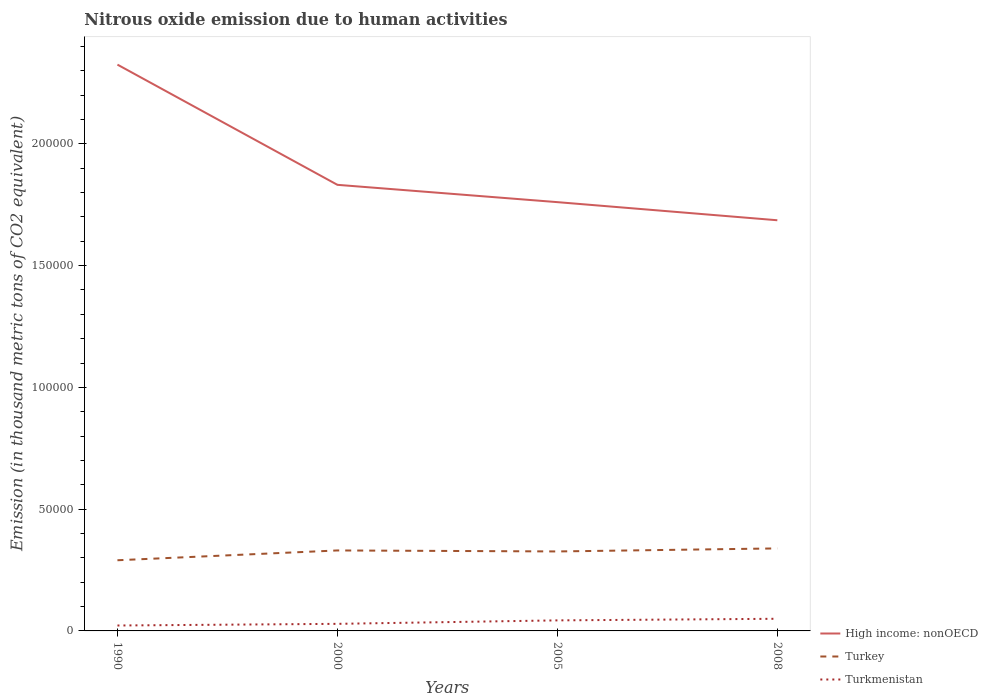Does the line corresponding to Turkey intersect with the line corresponding to Turkmenistan?
Your answer should be very brief. No. Across all years, what is the maximum amount of nitrous oxide emitted in High income: nonOECD?
Your answer should be compact. 1.69e+05. What is the total amount of nitrous oxide emitted in Turkey in the graph?
Keep it short and to the point. -1246.8. What is the difference between the highest and the second highest amount of nitrous oxide emitted in Turkey?
Your response must be concise. 4864.2. How many lines are there?
Your answer should be very brief. 3. How many years are there in the graph?
Make the answer very short. 4. What is the difference between two consecutive major ticks on the Y-axis?
Ensure brevity in your answer.  5.00e+04. Are the values on the major ticks of Y-axis written in scientific E-notation?
Your answer should be compact. No. How are the legend labels stacked?
Make the answer very short. Vertical. What is the title of the graph?
Offer a terse response. Nitrous oxide emission due to human activities. Does "French Polynesia" appear as one of the legend labels in the graph?
Provide a succinct answer. No. What is the label or title of the Y-axis?
Provide a short and direct response. Emission (in thousand metric tons of CO2 equivalent). What is the Emission (in thousand metric tons of CO2 equivalent) in High income: nonOECD in 1990?
Your answer should be compact. 2.33e+05. What is the Emission (in thousand metric tons of CO2 equivalent) in Turkey in 1990?
Provide a short and direct response. 2.90e+04. What is the Emission (in thousand metric tons of CO2 equivalent) of Turkmenistan in 1990?
Offer a very short reply. 2225.1. What is the Emission (in thousand metric tons of CO2 equivalent) of High income: nonOECD in 2000?
Give a very brief answer. 1.83e+05. What is the Emission (in thousand metric tons of CO2 equivalent) of Turkey in 2000?
Provide a succinct answer. 3.30e+04. What is the Emission (in thousand metric tons of CO2 equivalent) of Turkmenistan in 2000?
Provide a short and direct response. 2907.9. What is the Emission (in thousand metric tons of CO2 equivalent) of High income: nonOECD in 2005?
Give a very brief answer. 1.76e+05. What is the Emission (in thousand metric tons of CO2 equivalent) in Turkey in 2005?
Offer a terse response. 3.26e+04. What is the Emission (in thousand metric tons of CO2 equivalent) of Turkmenistan in 2005?
Provide a short and direct response. 4330.6. What is the Emission (in thousand metric tons of CO2 equivalent) in High income: nonOECD in 2008?
Keep it short and to the point. 1.69e+05. What is the Emission (in thousand metric tons of CO2 equivalent) of Turkey in 2008?
Your response must be concise. 3.39e+04. What is the Emission (in thousand metric tons of CO2 equivalent) of Turkmenistan in 2008?
Keep it short and to the point. 4987.1. Across all years, what is the maximum Emission (in thousand metric tons of CO2 equivalent) in High income: nonOECD?
Offer a terse response. 2.33e+05. Across all years, what is the maximum Emission (in thousand metric tons of CO2 equivalent) of Turkey?
Your response must be concise. 3.39e+04. Across all years, what is the maximum Emission (in thousand metric tons of CO2 equivalent) in Turkmenistan?
Make the answer very short. 4987.1. Across all years, what is the minimum Emission (in thousand metric tons of CO2 equivalent) of High income: nonOECD?
Offer a very short reply. 1.69e+05. Across all years, what is the minimum Emission (in thousand metric tons of CO2 equivalent) of Turkey?
Your answer should be very brief. 2.90e+04. Across all years, what is the minimum Emission (in thousand metric tons of CO2 equivalent) of Turkmenistan?
Offer a terse response. 2225.1. What is the total Emission (in thousand metric tons of CO2 equivalent) of High income: nonOECD in the graph?
Your response must be concise. 7.60e+05. What is the total Emission (in thousand metric tons of CO2 equivalent) of Turkey in the graph?
Your response must be concise. 1.29e+05. What is the total Emission (in thousand metric tons of CO2 equivalent) in Turkmenistan in the graph?
Keep it short and to the point. 1.45e+04. What is the difference between the Emission (in thousand metric tons of CO2 equivalent) of High income: nonOECD in 1990 and that in 2000?
Ensure brevity in your answer.  4.94e+04. What is the difference between the Emission (in thousand metric tons of CO2 equivalent) in Turkey in 1990 and that in 2000?
Provide a short and direct response. -4027.6. What is the difference between the Emission (in thousand metric tons of CO2 equivalent) in Turkmenistan in 1990 and that in 2000?
Offer a terse response. -682.8. What is the difference between the Emission (in thousand metric tons of CO2 equivalent) in High income: nonOECD in 1990 and that in 2005?
Make the answer very short. 5.65e+04. What is the difference between the Emission (in thousand metric tons of CO2 equivalent) in Turkey in 1990 and that in 2005?
Provide a short and direct response. -3617.4. What is the difference between the Emission (in thousand metric tons of CO2 equivalent) of Turkmenistan in 1990 and that in 2005?
Your response must be concise. -2105.5. What is the difference between the Emission (in thousand metric tons of CO2 equivalent) in High income: nonOECD in 1990 and that in 2008?
Offer a very short reply. 6.39e+04. What is the difference between the Emission (in thousand metric tons of CO2 equivalent) of Turkey in 1990 and that in 2008?
Give a very brief answer. -4864.2. What is the difference between the Emission (in thousand metric tons of CO2 equivalent) in Turkmenistan in 1990 and that in 2008?
Ensure brevity in your answer.  -2762. What is the difference between the Emission (in thousand metric tons of CO2 equivalent) in High income: nonOECD in 2000 and that in 2005?
Your response must be concise. 7109.4. What is the difference between the Emission (in thousand metric tons of CO2 equivalent) of Turkey in 2000 and that in 2005?
Your answer should be compact. 410.2. What is the difference between the Emission (in thousand metric tons of CO2 equivalent) in Turkmenistan in 2000 and that in 2005?
Offer a terse response. -1422.7. What is the difference between the Emission (in thousand metric tons of CO2 equivalent) of High income: nonOECD in 2000 and that in 2008?
Your answer should be very brief. 1.45e+04. What is the difference between the Emission (in thousand metric tons of CO2 equivalent) of Turkey in 2000 and that in 2008?
Offer a terse response. -836.6. What is the difference between the Emission (in thousand metric tons of CO2 equivalent) of Turkmenistan in 2000 and that in 2008?
Provide a short and direct response. -2079.2. What is the difference between the Emission (in thousand metric tons of CO2 equivalent) in High income: nonOECD in 2005 and that in 2008?
Your answer should be compact. 7440. What is the difference between the Emission (in thousand metric tons of CO2 equivalent) in Turkey in 2005 and that in 2008?
Offer a terse response. -1246.8. What is the difference between the Emission (in thousand metric tons of CO2 equivalent) of Turkmenistan in 2005 and that in 2008?
Your answer should be compact. -656.5. What is the difference between the Emission (in thousand metric tons of CO2 equivalent) in High income: nonOECD in 1990 and the Emission (in thousand metric tons of CO2 equivalent) in Turkey in 2000?
Your response must be concise. 1.99e+05. What is the difference between the Emission (in thousand metric tons of CO2 equivalent) in High income: nonOECD in 1990 and the Emission (in thousand metric tons of CO2 equivalent) in Turkmenistan in 2000?
Offer a very short reply. 2.30e+05. What is the difference between the Emission (in thousand metric tons of CO2 equivalent) of Turkey in 1990 and the Emission (in thousand metric tons of CO2 equivalent) of Turkmenistan in 2000?
Ensure brevity in your answer.  2.61e+04. What is the difference between the Emission (in thousand metric tons of CO2 equivalent) of High income: nonOECD in 1990 and the Emission (in thousand metric tons of CO2 equivalent) of Turkey in 2005?
Provide a succinct answer. 2.00e+05. What is the difference between the Emission (in thousand metric tons of CO2 equivalent) in High income: nonOECD in 1990 and the Emission (in thousand metric tons of CO2 equivalent) in Turkmenistan in 2005?
Keep it short and to the point. 2.28e+05. What is the difference between the Emission (in thousand metric tons of CO2 equivalent) in Turkey in 1990 and the Emission (in thousand metric tons of CO2 equivalent) in Turkmenistan in 2005?
Give a very brief answer. 2.47e+04. What is the difference between the Emission (in thousand metric tons of CO2 equivalent) in High income: nonOECD in 1990 and the Emission (in thousand metric tons of CO2 equivalent) in Turkey in 2008?
Your response must be concise. 1.99e+05. What is the difference between the Emission (in thousand metric tons of CO2 equivalent) of High income: nonOECD in 1990 and the Emission (in thousand metric tons of CO2 equivalent) of Turkmenistan in 2008?
Keep it short and to the point. 2.28e+05. What is the difference between the Emission (in thousand metric tons of CO2 equivalent) in Turkey in 1990 and the Emission (in thousand metric tons of CO2 equivalent) in Turkmenistan in 2008?
Offer a terse response. 2.40e+04. What is the difference between the Emission (in thousand metric tons of CO2 equivalent) in High income: nonOECD in 2000 and the Emission (in thousand metric tons of CO2 equivalent) in Turkey in 2005?
Make the answer very short. 1.51e+05. What is the difference between the Emission (in thousand metric tons of CO2 equivalent) of High income: nonOECD in 2000 and the Emission (in thousand metric tons of CO2 equivalent) of Turkmenistan in 2005?
Offer a terse response. 1.79e+05. What is the difference between the Emission (in thousand metric tons of CO2 equivalent) of Turkey in 2000 and the Emission (in thousand metric tons of CO2 equivalent) of Turkmenistan in 2005?
Offer a terse response. 2.87e+04. What is the difference between the Emission (in thousand metric tons of CO2 equivalent) of High income: nonOECD in 2000 and the Emission (in thousand metric tons of CO2 equivalent) of Turkey in 2008?
Ensure brevity in your answer.  1.49e+05. What is the difference between the Emission (in thousand metric tons of CO2 equivalent) in High income: nonOECD in 2000 and the Emission (in thousand metric tons of CO2 equivalent) in Turkmenistan in 2008?
Give a very brief answer. 1.78e+05. What is the difference between the Emission (in thousand metric tons of CO2 equivalent) of Turkey in 2000 and the Emission (in thousand metric tons of CO2 equivalent) of Turkmenistan in 2008?
Make the answer very short. 2.81e+04. What is the difference between the Emission (in thousand metric tons of CO2 equivalent) of High income: nonOECD in 2005 and the Emission (in thousand metric tons of CO2 equivalent) of Turkey in 2008?
Make the answer very short. 1.42e+05. What is the difference between the Emission (in thousand metric tons of CO2 equivalent) of High income: nonOECD in 2005 and the Emission (in thousand metric tons of CO2 equivalent) of Turkmenistan in 2008?
Ensure brevity in your answer.  1.71e+05. What is the difference between the Emission (in thousand metric tons of CO2 equivalent) of Turkey in 2005 and the Emission (in thousand metric tons of CO2 equivalent) of Turkmenistan in 2008?
Keep it short and to the point. 2.76e+04. What is the average Emission (in thousand metric tons of CO2 equivalent) of High income: nonOECD per year?
Provide a short and direct response. 1.90e+05. What is the average Emission (in thousand metric tons of CO2 equivalent) in Turkey per year?
Your answer should be very brief. 3.21e+04. What is the average Emission (in thousand metric tons of CO2 equivalent) in Turkmenistan per year?
Offer a very short reply. 3612.68. In the year 1990, what is the difference between the Emission (in thousand metric tons of CO2 equivalent) in High income: nonOECD and Emission (in thousand metric tons of CO2 equivalent) in Turkey?
Your answer should be compact. 2.03e+05. In the year 1990, what is the difference between the Emission (in thousand metric tons of CO2 equivalent) in High income: nonOECD and Emission (in thousand metric tons of CO2 equivalent) in Turkmenistan?
Offer a terse response. 2.30e+05. In the year 1990, what is the difference between the Emission (in thousand metric tons of CO2 equivalent) in Turkey and Emission (in thousand metric tons of CO2 equivalent) in Turkmenistan?
Ensure brevity in your answer.  2.68e+04. In the year 2000, what is the difference between the Emission (in thousand metric tons of CO2 equivalent) of High income: nonOECD and Emission (in thousand metric tons of CO2 equivalent) of Turkey?
Make the answer very short. 1.50e+05. In the year 2000, what is the difference between the Emission (in thousand metric tons of CO2 equivalent) of High income: nonOECD and Emission (in thousand metric tons of CO2 equivalent) of Turkmenistan?
Give a very brief answer. 1.80e+05. In the year 2000, what is the difference between the Emission (in thousand metric tons of CO2 equivalent) of Turkey and Emission (in thousand metric tons of CO2 equivalent) of Turkmenistan?
Keep it short and to the point. 3.01e+04. In the year 2005, what is the difference between the Emission (in thousand metric tons of CO2 equivalent) in High income: nonOECD and Emission (in thousand metric tons of CO2 equivalent) in Turkey?
Offer a very short reply. 1.43e+05. In the year 2005, what is the difference between the Emission (in thousand metric tons of CO2 equivalent) of High income: nonOECD and Emission (in thousand metric tons of CO2 equivalent) of Turkmenistan?
Ensure brevity in your answer.  1.72e+05. In the year 2005, what is the difference between the Emission (in thousand metric tons of CO2 equivalent) of Turkey and Emission (in thousand metric tons of CO2 equivalent) of Turkmenistan?
Your answer should be very brief. 2.83e+04. In the year 2008, what is the difference between the Emission (in thousand metric tons of CO2 equivalent) in High income: nonOECD and Emission (in thousand metric tons of CO2 equivalent) in Turkey?
Ensure brevity in your answer.  1.35e+05. In the year 2008, what is the difference between the Emission (in thousand metric tons of CO2 equivalent) in High income: nonOECD and Emission (in thousand metric tons of CO2 equivalent) in Turkmenistan?
Your response must be concise. 1.64e+05. In the year 2008, what is the difference between the Emission (in thousand metric tons of CO2 equivalent) of Turkey and Emission (in thousand metric tons of CO2 equivalent) of Turkmenistan?
Ensure brevity in your answer.  2.89e+04. What is the ratio of the Emission (in thousand metric tons of CO2 equivalent) in High income: nonOECD in 1990 to that in 2000?
Offer a terse response. 1.27. What is the ratio of the Emission (in thousand metric tons of CO2 equivalent) of Turkey in 1990 to that in 2000?
Provide a succinct answer. 0.88. What is the ratio of the Emission (in thousand metric tons of CO2 equivalent) of Turkmenistan in 1990 to that in 2000?
Offer a very short reply. 0.77. What is the ratio of the Emission (in thousand metric tons of CO2 equivalent) in High income: nonOECD in 1990 to that in 2005?
Provide a succinct answer. 1.32. What is the ratio of the Emission (in thousand metric tons of CO2 equivalent) in Turkey in 1990 to that in 2005?
Give a very brief answer. 0.89. What is the ratio of the Emission (in thousand metric tons of CO2 equivalent) in Turkmenistan in 1990 to that in 2005?
Your answer should be compact. 0.51. What is the ratio of the Emission (in thousand metric tons of CO2 equivalent) of High income: nonOECD in 1990 to that in 2008?
Offer a very short reply. 1.38. What is the ratio of the Emission (in thousand metric tons of CO2 equivalent) in Turkey in 1990 to that in 2008?
Your response must be concise. 0.86. What is the ratio of the Emission (in thousand metric tons of CO2 equivalent) in Turkmenistan in 1990 to that in 2008?
Provide a short and direct response. 0.45. What is the ratio of the Emission (in thousand metric tons of CO2 equivalent) of High income: nonOECD in 2000 to that in 2005?
Make the answer very short. 1.04. What is the ratio of the Emission (in thousand metric tons of CO2 equivalent) in Turkey in 2000 to that in 2005?
Give a very brief answer. 1.01. What is the ratio of the Emission (in thousand metric tons of CO2 equivalent) in Turkmenistan in 2000 to that in 2005?
Your answer should be very brief. 0.67. What is the ratio of the Emission (in thousand metric tons of CO2 equivalent) in High income: nonOECD in 2000 to that in 2008?
Offer a very short reply. 1.09. What is the ratio of the Emission (in thousand metric tons of CO2 equivalent) of Turkey in 2000 to that in 2008?
Give a very brief answer. 0.98. What is the ratio of the Emission (in thousand metric tons of CO2 equivalent) in Turkmenistan in 2000 to that in 2008?
Keep it short and to the point. 0.58. What is the ratio of the Emission (in thousand metric tons of CO2 equivalent) of High income: nonOECD in 2005 to that in 2008?
Give a very brief answer. 1.04. What is the ratio of the Emission (in thousand metric tons of CO2 equivalent) of Turkey in 2005 to that in 2008?
Your answer should be very brief. 0.96. What is the ratio of the Emission (in thousand metric tons of CO2 equivalent) in Turkmenistan in 2005 to that in 2008?
Your response must be concise. 0.87. What is the difference between the highest and the second highest Emission (in thousand metric tons of CO2 equivalent) in High income: nonOECD?
Give a very brief answer. 4.94e+04. What is the difference between the highest and the second highest Emission (in thousand metric tons of CO2 equivalent) of Turkey?
Your response must be concise. 836.6. What is the difference between the highest and the second highest Emission (in thousand metric tons of CO2 equivalent) in Turkmenistan?
Provide a succinct answer. 656.5. What is the difference between the highest and the lowest Emission (in thousand metric tons of CO2 equivalent) of High income: nonOECD?
Your answer should be very brief. 6.39e+04. What is the difference between the highest and the lowest Emission (in thousand metric tons of CO2 equivalent) in Turkey?
Ensure brevity in your answer.  4864.2. What is the difference between the highest and the lowest Emission (in thousand metric tons of CO2 equivalent) of Turkmenistan?
Give a very brief answer. 2762. 